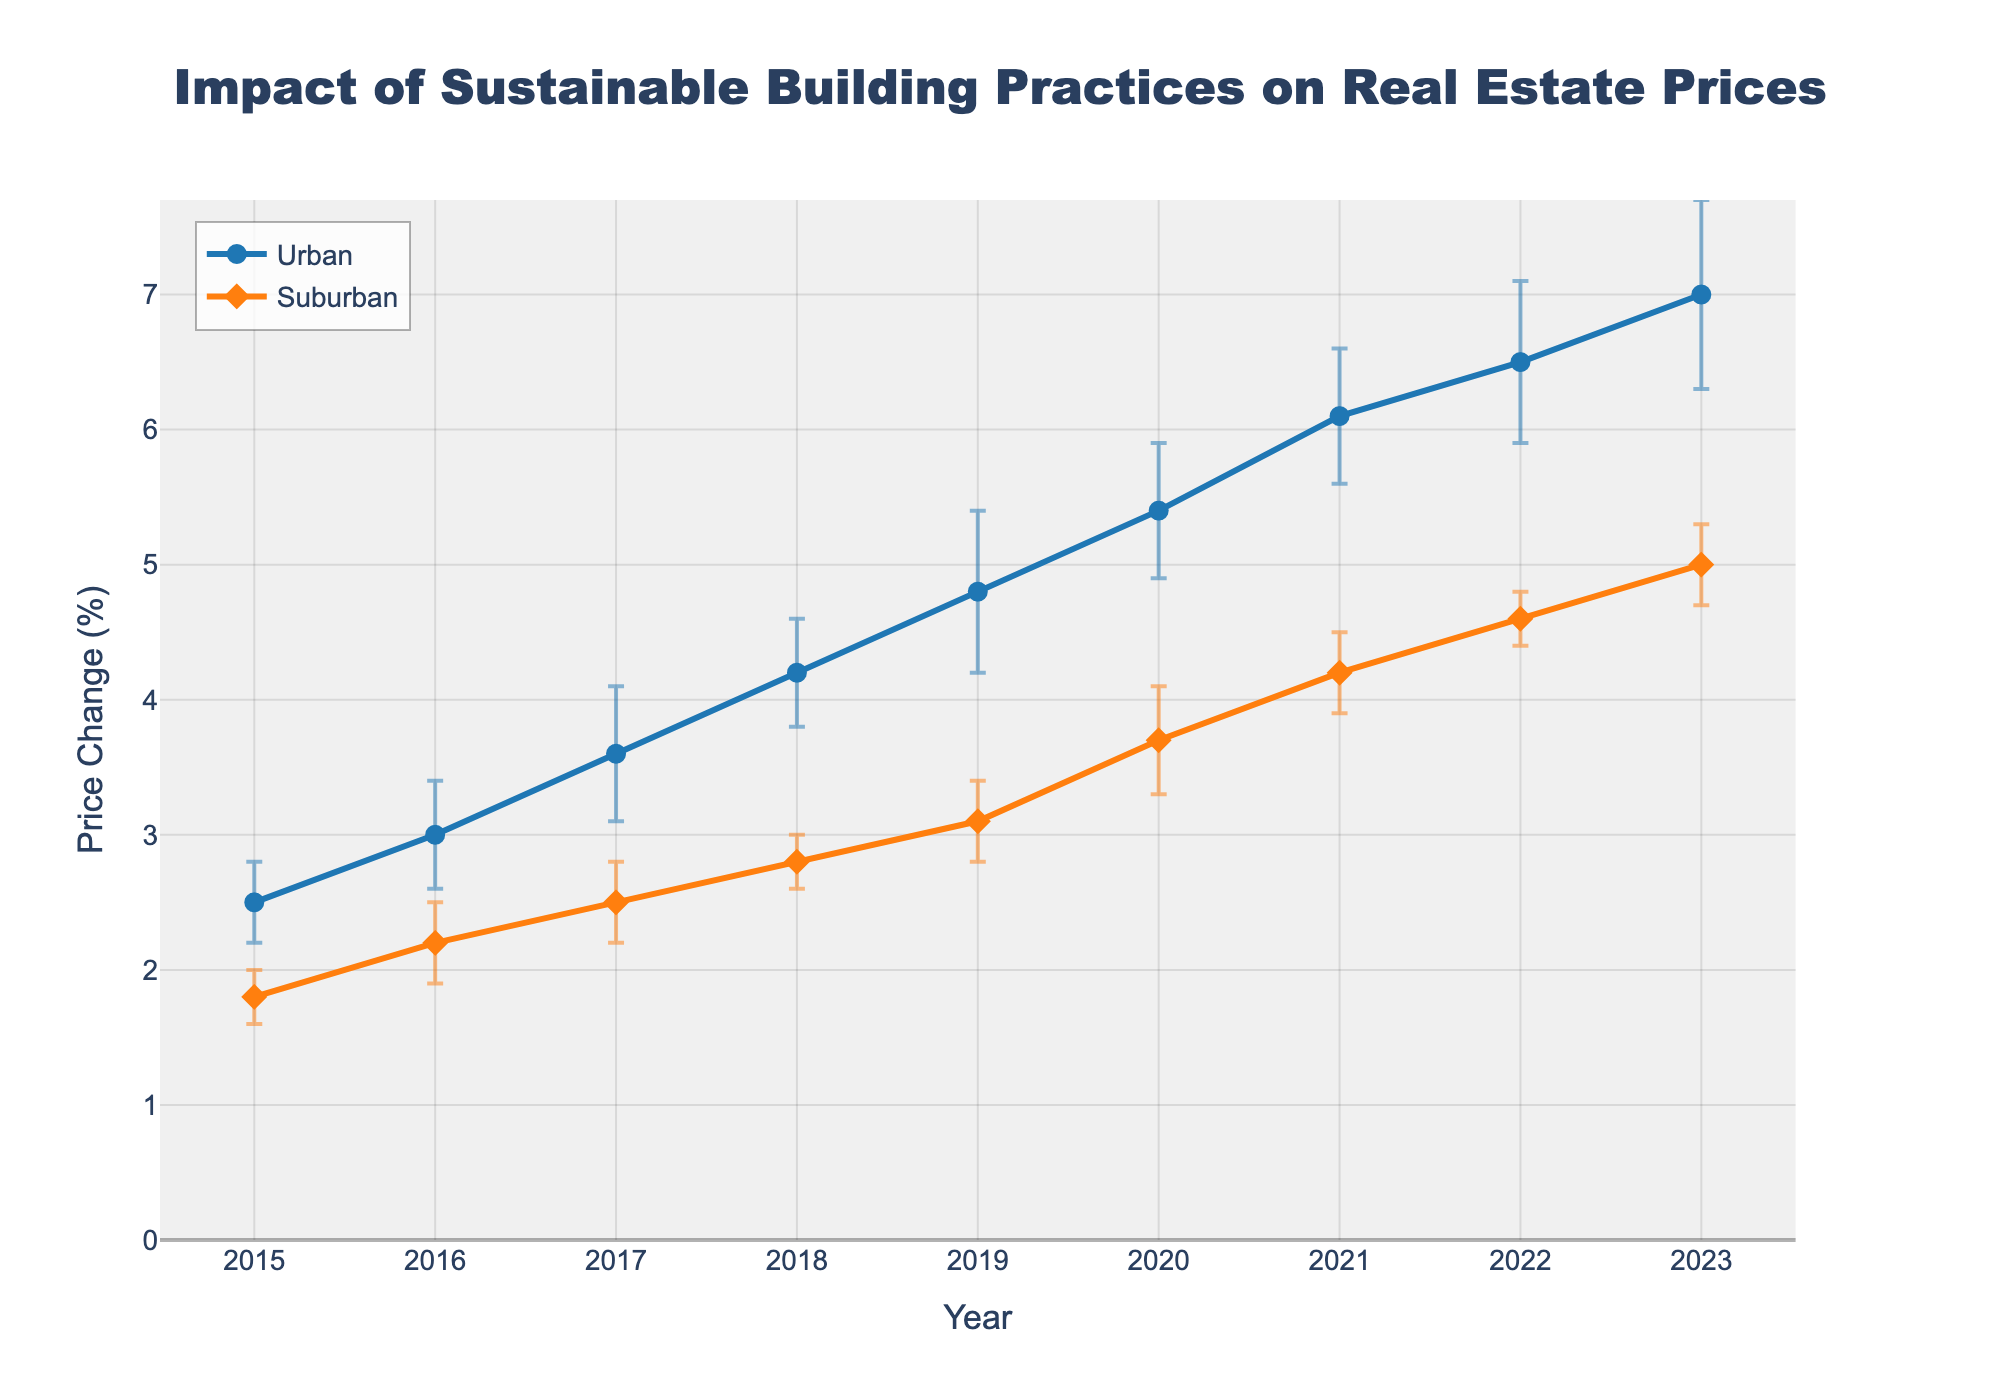What is the title of the plot? The title of the plot is usually displayed at the top in bold, large text. It provides a summary of what the data represents. In this case, it is "Impact of Sustainable Building Practices on Real Estate Prices".
Answer: Impact of Sustainable Building Practices on Real Estate Prices What are the y-axis labels? The y-axis labels typically indicate the type of data being measured. In this figure, the y-axis label is "Price Change (%)", indicating the percentage change in real estate prices.
Answer: Price Change (%) Which year shows the highest price change percentage for urban areas? To find the year with the highest price change percentage for urban areas, look at the data points for the urban line and identify the peak value. The highest value is 7.0% in the year 2023.
Answer: 2023 How do the error bars for suburban areas in 2015 compare to the urban areas in the same year? Error bars represent the standard error around the data points. For 2015, suburban error bars are smaller (0.2) compared to urban error bars (0.3), indicating less variability in the data for suburban areas.
Answer: Suburban error bars are smaller What is the average price change percentage for suburban areas from 2015 to 2018? To calculate the average price change, sum the price change percentages for suburban areas from 2015 (1.8), 2016 (2.2), 2017 (2.5), and 2018 (2.8) and then divide by the number of years. (1.8 + 2.2 + 2.5 + 2.8) / 4 = 2.325%.
Answer: 2.325% Which area shows more consistent growth in real estate prices based on the standard error bars? Consistent growth can be indicated by smaller and more uniform error bars. Urban areas display varying error bars, while suburban areas have relatively uniform and smaller error bars over the years. Hence, suburban areas exhibit more consistent growth.
Answer: Suburban areas Compare the price change percentage between urban and suburban areas for the year 2020. For 2020, the urban price change is 5.4% and the suburban price change is 3.7%. To compare, 5.4% (urban) is greater than 3.7% (suburban).
Answer: Urban areas have a higher price change percentage What is the trend in the price change percentage for urban areas from 2015 to 2023? Observing the urban line from 2015 to 2023, there is a consistent upward trend, indicating that the price change percentage is increasing over the years.
Answer: Increasing What is the difference in price change percentage between urban and suburban areas in 2023? The price change percentage for 2023 is 7.0% for urban areas and 5.0% for suburban areas. The difference is 7.0% - 5.0% = 2.0%.
Answer: 2.0% Which area had the highest price change percentage in 2019, and what is the value? By comparing the data points for 2019, urban areas had a price change percentage of 4.8% while suburban areas had 3.1%. The highest is urban with 4.8%.
Answer: Urban areas, 4.8% 